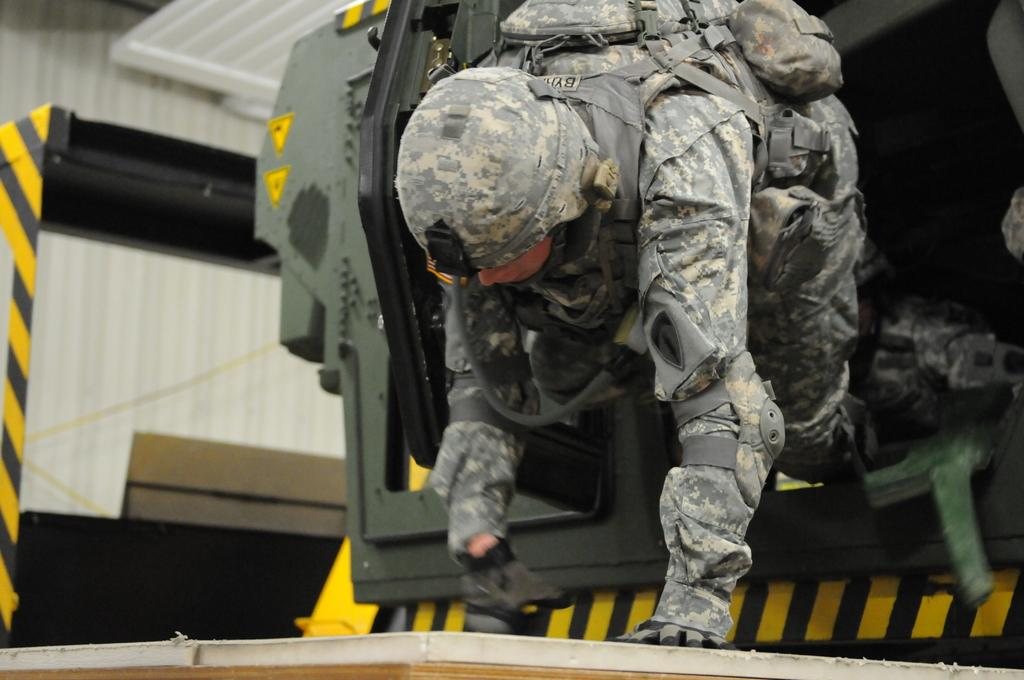Who is the main subject in the image? There is a person in the center of the image. What is the person wearing? The person is wearing a uniform. What action is the person performing? The person appears to be crawling. What can be seen in the background of the image? There are many other objects in the background of the image. What type of lunch is the person eating in the image? There is no lunch present in the image; the person is crawling and wearing a uniform. Can you see any dolls in the image? There are no dolls present in the image; the focus is on the person crawling and the objects in the background. 